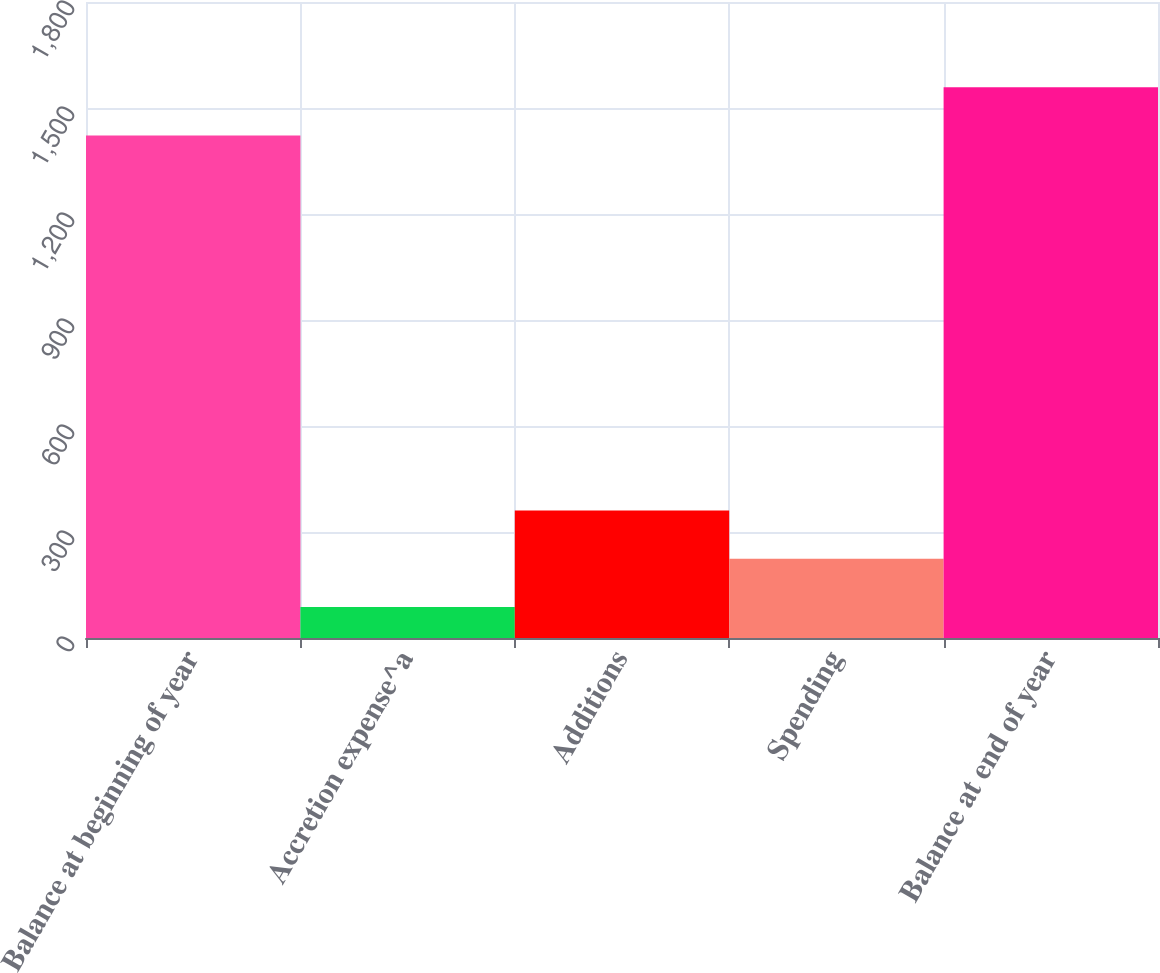<chart> <loc_0><loc_0><loc_500><loc_500><bar_chart><fcel>Balance at beginning of year<fcel>Accretion expense^a<fcel>Additions<fcel>Spending<fcel>Balance at end of year<nl><fcel>1422<fcel>88<fcel>361<fcel>224.5<fcel>1558.5<nl></chart> 